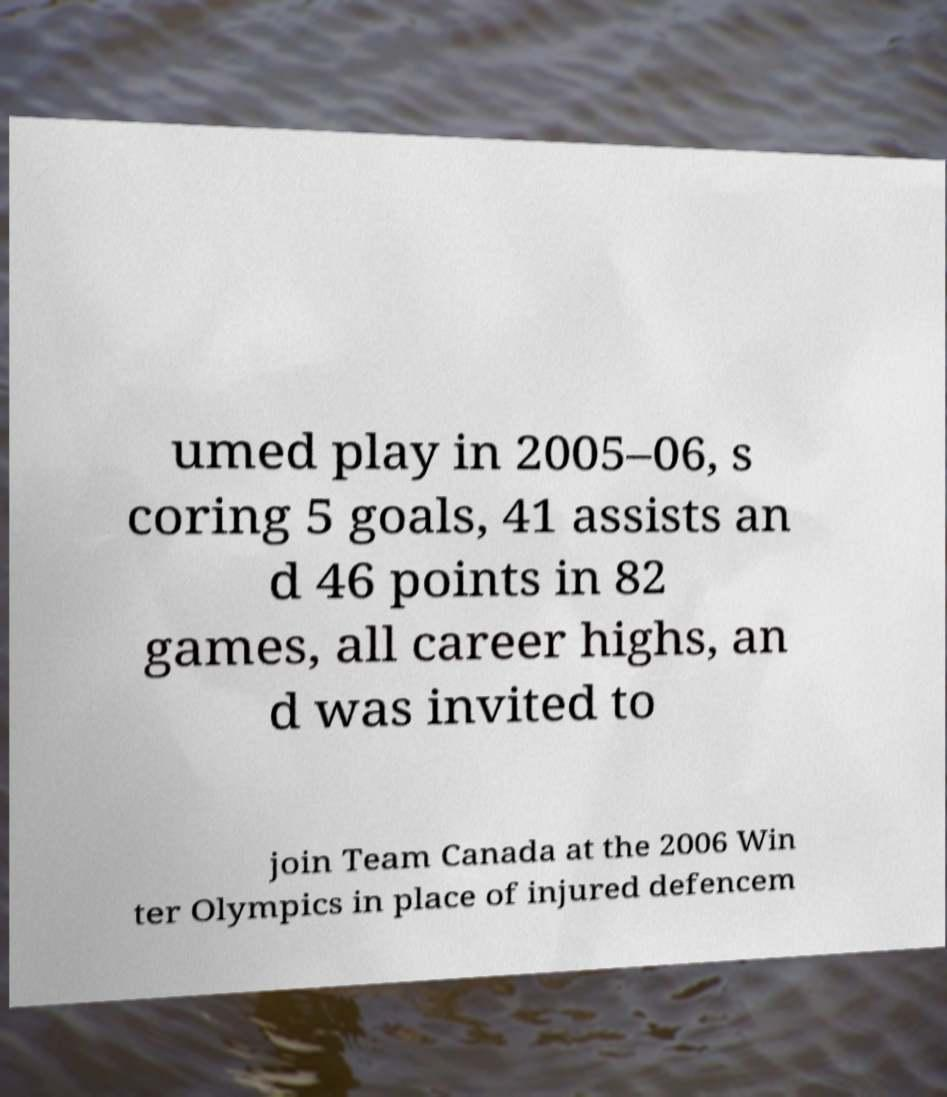Please read and relay the text visible in this image. What does it say? umed play in 2005–06, s coring 5 goals, 41 assists an d 46 points in 82 games, all career highs, an d was invited to join Team Canada at the 2006 Win ter Olympics in place of injured defencem 